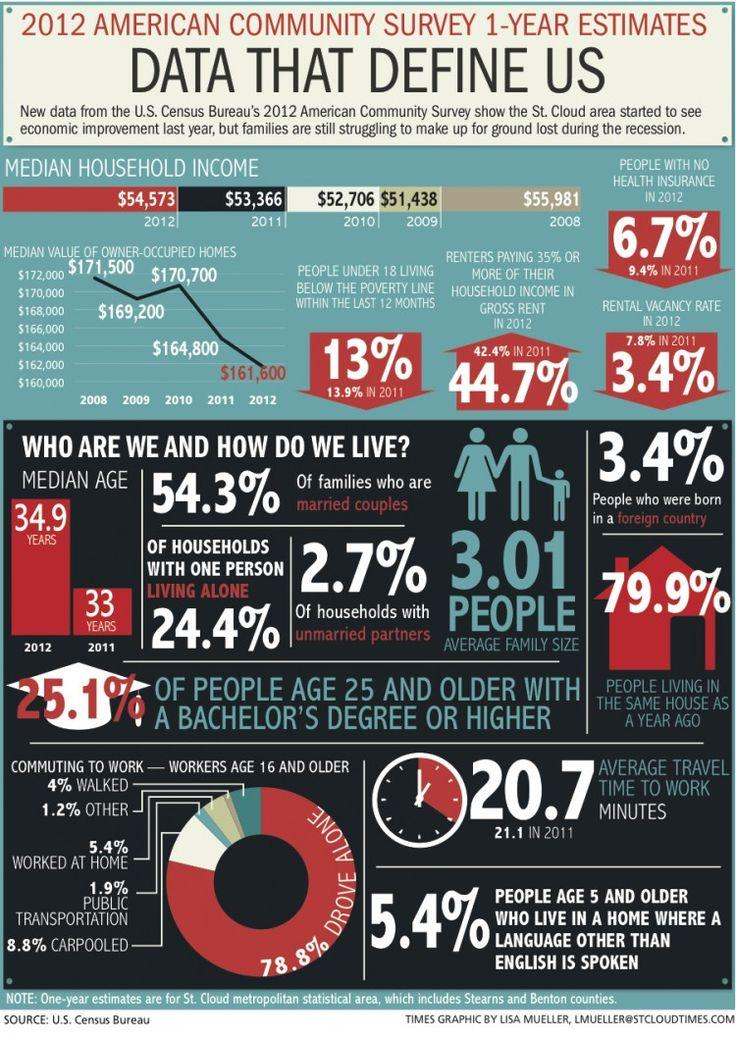Highlight a few significant elements in this photo. According to data for workers aged 16 and older, walking is the fourth most commonly used mode of commuting to work. The median household income increased by $1,928 from 2009 to 2011. In 2011 and 2012, 2.3% of renters paid 35% or more of their household income in gross rent, which represents an increase of 0.1% from the previous year. In 2011, approximately 2.7% fewer people in the United States were without health insurance compared to the previous year. The infographic shows that in 2010, median household income was the second lowest among all years listed. 